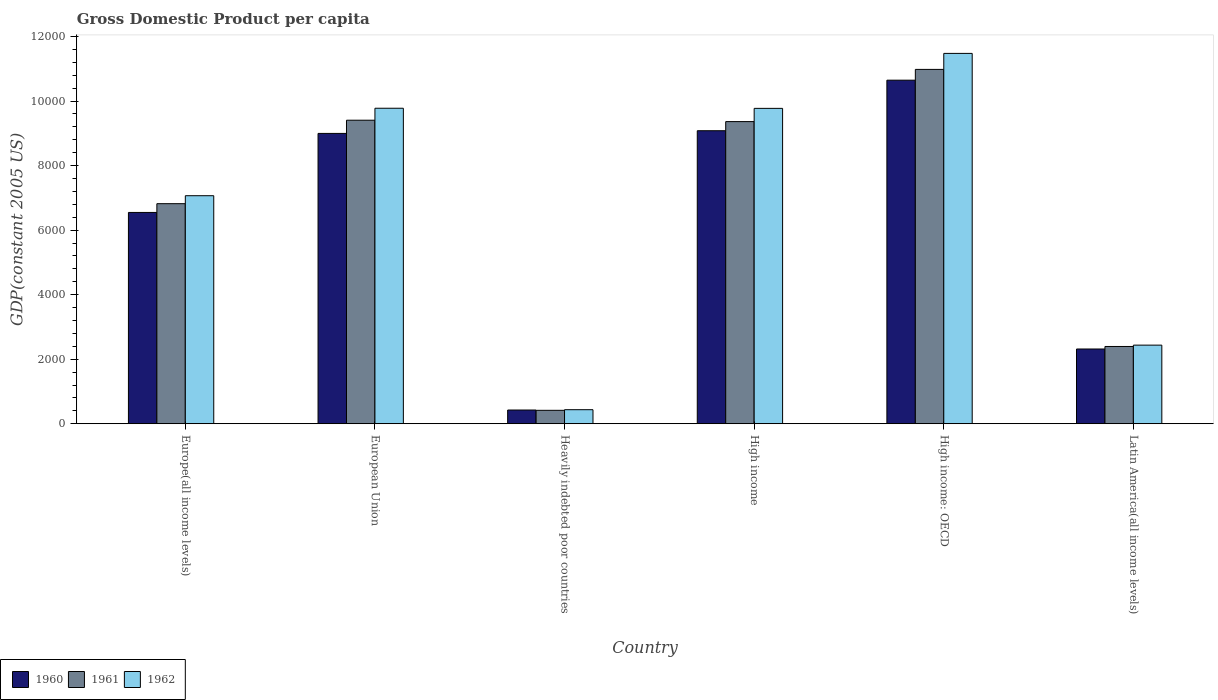Are the number of bars per tick equal to the number of legend labels?
Provide a short and direct response. Yes. How many bars are there on the 4th tick from the left?
Provide a short and direct response. 3. How many bars are there on the 3rd tick from the right?
Ensure brevity in your answer.  3. What is the label of the 6th group of bars from the left?
Your answer should be very brief. Latin America(all income levels). In how many cases, is the number of bars for a given country not equal to the number of legend labels?
Keep it short and to the point. 0. What is the GDP per capita in 1962 in Europe(all income levels)?
Provide a short and direct response. 7066.73. Across all countries, what is the maximum GDP per capita in 1961?
Give a very brief answer. 1.10e+04. Across all countries, what is the minimum GDP per capita in 1960?
Provide a short and direct response. 424.89. In which country was the GDP per capita in 1962 maximum?
Your answer should be compact. High income: OECD. In which country was the GDP per capita in 1962 minimum?
Ensure brevity in your answer.  Heavily indebted poor countries. What is the total GDP per capita in 1962 in the graph?
Offer a terse response. 4.10e+04. What is the difference between the GDP per capita in 1960 in Europe(all income levels) and that in High income?
Your answer should be compact. -2532.78. What is the difference between the GDP per capita in 1962 in Heavily indebted poor countries and the GDP per capita in 1960 in High income?
Ensure brevity in your answer.  -8645.59. What is the average GDP per capita in 1962 per country?
Provide a short and direct response. 6827.66. What is the difference between the GDP per capita of/in 1960 and GDP per capita of/in 1962 in European Union?
Your answer should be very brief. -779.83. What is the ratio of the GDP per capita in 1960 in European Union to that in Heavily indebted poor countries?
Your response must be concise. 21.18. What is the difference between the highest and the second highest GDP per capita in 1960?
Ensure brevity in your answer.  83.28. What is the difference between the highest and the lowest GDP per capita in 1961?
Your answer should be very brief. 1.06e+04. Is the sum of the GDP per capita in 1960 in European Union and Latin America(all income levels) greater than the maximum GDP per capita in 1961 across all countries?
Ensure brevity in your answer.  Yes. Is it the case that in every country, the sum of the GDP per capita in 1961 and GDP per capita in 1960 is greater than the GDP per capita in 1962?
Your answer should be very brief. Yes. Are all the bars in the graph horizontal?
Make the answer very short. No. How many countries are there in the graph?
Your response must be concise. 6. What is the difference between two consecutive major ticks on the Y-axis?
Offer a terse response. 2000. Where does the legend appear in the graph?
Provide a short and direct response. Bottom left. How many legend labels are there?
Make the answer very short. 3. How are the legend labels stacked?
Your response must be concise. Horizontal. What is the title of the graph?
Provide a succinct answer. Gross Domestic Product per capita. What is the label or title of the X-axis?
Your answer should be very brief. Country. What is the label or title of the Y-axis?
Keep it short and to the point. GDP(constant 2005 US). What is the GDP(constant 2005 US) of 1960 in Europe(all income levels)?
Your answer should be very brief. 6547.96. What is the GDP(constant 2005 US) in 1961 in Europe(all income levels)?
Offer a terse response. 6819.79. What is the GDP(constant 2005 US) of 1962 in Europe(all income levels)?
Your response must be concise. 7066.73. What is the GDP(constant 2005 US) of 1960 in European Union?
Provide a succinct answer. 8997.47. What is the GDP(constant 2005 US) of 1961 in European Union?
Ensure brevity in your answer.  9406.28. What is the GDP(constant 2005 US) of 1962 in European Union?
Provide a short and direct response. 9777.3. What is the GDP(constant 2005 US) of 1960 in Heavily indebted poor countries?
Make the answer very short. 424.89. What is the GDP(constant 2005 US) in 1961 in Heavily indebted poor countries?
Give a very brief answer. 415.63. What is the GDP(constant 2005 US) in 1962 in Heavily indebted poor countries?
Keep it short and to the point. 435.15. What is the GDP(constant 2005 US) in 1960 in High income?
Provide a succinct answer. 9080.74. What is the GDP(constant 2005 US) of 1961 in High income?
Your answer should be very brief. 9363.39. What is the GDP(constant 2005 US) in 1962 in High income?
Make the answer very short. 9773.42. What is the GDP(constant 2005 US) in 1960 in High income: OECD?
Ensure brevity in your answer.  1.06e+04. What is the GDP(constant 2005 US) in 1961 in High income: OECD?
Give a very brief answer. 1.10e+04. What is the GDP(constant 2005 US) in 1962 in High income: OECD?
Your answer should be very brief. 1.15e+04. What is the GDP(constant 2005 US) of 1960 in Latin America(all income levels)?
Provide a succinct answer. 2316.36. What is the GDP(constant 2005 US) in 1961 in Latin America(all income levels)?
Offer a very short reply. 2394.33. What is the GDP(constant 2005 US) in 1962 in Latin America(all income levels)?
Ensure brevity in your answer.  2436.18. Across all countries, what is the maximum GDP(constant 2005 US) of 1960?
Give a very brief answer. 1.06e+04. Across all countries, what is the maximum GDP(constant 2005 US) of 1961?
Give a very brief answer. 1.10e+04. Across all countries, what is the maximum GDP(constant 2005 US) in 1962?
Your answer should be very brief. 1.15e+04. Across all countries, what is the minimum GDP(constant 2005 US) of 1960?
Your response must be concise. 424.89. Across all countries, what is the minimum GDP(constant 2005 US) of 1961?
Provide a succinct answer. 415.63. Across all countries, what is the minimum GDP(constant 2005 US) in 1962?
Ensure brevity in your answer.  435.15. What is the total GDP(constant 2005 US) of 1960 in the graph?
Offer a very short reply. 3.80e+04. What is the total GDP(constant 2005 US) of 1961 in the graph?
Ensure brevity in your answer.  3.94e+04. What is the total GDP(constant 2005 US) in 1962 in the graph?
Your answer should be compact. 4.10e+04. What is the difference between the GDP(constant 2005 US) in 1960 in Europe(all income levels) and that in European Union?
Your answer should be compact. -2449.5. What is the difference between the GDP(constant 2005 US) of 1961 in Europe(all income levels) and that in European Union?
Offer a very short reply. -2586.48. What is the difference between the GDP(constant 2005 US) in 1962 in Europe(all income levels) and that in European Union?
Your answer should be compact. -2710.56. What is the difference between the GDP(constant 2005 US) of 1960 in Europe(all income levels) and that in Heavily indebted poor countries?
Your response must be concise. 6123.07. What is the difference between the GDP(constant 2005 US) of 1961 in Europe(all income levels) and that in Heavily indebted poor countries?
Give a very brief answer. 6404.17. What is the difference between the GDP(constant 2005 US) in 1962 in Europe(all income levels) and that in Heavily indebted poor countries?
Give a very brief answer. 6631.58. What is the difference between the GDP(constant 2005 US) in 1960 in Europe(all income levels) and that in High income?
Provide a short and direct response. -2532.78. What is the difference between the GDP(constant 2005 US) of 1961 in Europe(all income levels) and that in High income?
Provide a short and direct response. -2543.6. What is the difference between the GDP(constant 2005 US) in 1962 in Europe(all income levels) and that in High income?
Make the answer very short. -2706.68. What is the difference between the GDP(constant 2005 US) of 1960 in Europe(all income levels) and that in High income: OECD?
Your answer should be compact. -4099.09. What is the difference between the GDP(constant 2005 US) in 1961 in Europe(all income levels) and that in High income: OECD?
Your answer should be compact. -4161.11. What is the difference between the GDP(constant 2005 US) of 1962 in Europe(all income levels) and that in High income: OECD?
Your answer should be very brief. -4410.44. What is the difference between the GDP(constant 2005 US) in 1960 in Europe(all income levels) and that in Latin America(all income levels)?
Your answer should be compact. 4231.61. What is the difference between the GDP(constant 2005 US) in 1961 in Europe(all income levels) and that in Latin America(all income levels)?
Your response must be concise. 4425.47. What is the difference between the GDP(constant 2005 US) of 1962 in Europe(all income levels) and that in Latin America(all income levels)?
Make the answer very short. 4630.56. What is the difference between the GDP(constant 2005 US) in 1960 in European Union and that in Heavily indebted poor countries?
Offer a terse response. 8572.57. What is the difference between the GDP(constant 2005 US) of 1961 in European Union and that in Heavily indebted poor countries?
Make the answer very short. 8990.65. What is the difference between the GDP(constant 2005 US) of 1962 in European Union and that in Heavily indebted poor countries?
Make the answer very short. 9342.14. What is the difference between the GDP(constant 2005 US) of 1960 in European Union and that in High income?
Your answer should be very brief. -83.28. What is the difference between the GDP(constant 2005 US) of 1961 in European Union and that in High income?
Your answer should be compact. 42.89. What is the difference between the GDP(constant 2005 US) of 1962 in European Union and that in High income?
Provide a short and direct response. 3.88. What is the difference between the GDP(constant 2005 US) of 1960 in European Union and that in High income: OECD?
Provide a succinct answer. -1649.59. What is the difference between the GDP(constant 2005 US) of 1961 in European Union and that in High income: OECD?
Offer a very short reply. -1574.63. What is the difference between the GDP(constant 2005 US) in 1962 in European Union and that in High income: OECD?
Offer a very short reply. -1699.88. What is the difference between the GDP(constant 2005 US) in 1960 in European Union and that in Latin America(all income levels)?
Your answer should be compact. 6681.11. What is the difference between the GDP(constant 2005 US) of 1961 in European Union and that in Latin America(all income levels)?
Ensure brevity in your answer.  7011.95. What is the difference between the GDP(constant 2005 US) of 1962 in European Union and that in Latin America(all income levels)?
Provide a succinct answer. 7341.12. What is the difference between the GDP(constant 2005 US) in 1960 in Heavily indebted poor countries and that in High income?
Keep it short and to the point. -8655.85. What is the difference between the GDP(constant 2005 US) of 1961 in Heavily indebted poor countries and that in High income?
Provide a short and direct response. -8947.77. What is the difference between the GDP(constant 2005 US) in 1962 in Heavily indebted poor countries and that in High income?
Provide a succinct answer. -9338.26. What is the difference between the GDP(constant 2005 US) in 1960 in Heavily indebted poor countries and that in High income: OECD?
Ensure brevity in your answer.  -1.02e+04. What is the difference between the GDP(constant 2005 US) of 1961 in Heavily indebted poor countries and that in High income: OECD?
Keep it short and to the point. -1.06e+04. What is the difference between the GDP(constant 2005 US) in 1962 in Heavily indebted poor countries and that in High income: OECD?
Provide a short and direct response. -1.10e+04. What is the difference between the GDP(constant 2005 US) in 1960 in Heavily indebted poor countries and that in Latin America(all income levels)?
Provide a short and direct response. -1891.46. What is the difference between the GDP(constant 2005 US) of 1961 in Heavily indebted poor countries and that in Latin America(all income levels)?
Give a very brief answer. -1978.7. What is the difference between the GDP(constant 2005 US) of 1962 in Heavily indebted poor countries and that in Latin America(all income levels)?
Offer a terse response. -2001.03. What is the difference between the GDP(constant 2005 US) of 1960 in High income and that in High income: OECD?
Provide a short and direct response. -1566.31. What is the difference between the GDP(constant 2005 US) in 1961 in High income and that in High income: OECD?
Keep it short and to the point. -1617.52. What is the difference between the GDP(constant 2005 US) of 1962 in High income and that in High income: OECD?
Ensure brevity in your answer.  -1703.76. What is the difference between the GDP(constant 2005 US) of 1960 in High income and that in Latin America(all income levels)?
Your answer should be compact. 6764.39. What is the difference between the GDP(constant 2005 US) in 1961 in High income and that in Latin America(all income levels)?
Provide a succinct answer. 6969.06. What is the difference between the GDP(constant 2005 US) in 1962 in High income and that in Latin America(all income levels)?
Offer a very short reply. 7337.24. What is the difference between the GDP(constant 2005 US) in 1960 in High income: OECD and that in Latin America(all income levels)?
Ensure brevity in your answer.  8330.7. What is the difference between the GDP(constant 2005 US) in 1961 in High income: OECD and that in Latin America(all income levels)?
Your answer should be very brief. 8586.58. What is the difference between the GDP(constant 2005 US) of 1962 in High income: OECD and that in Latin America(all income levels)?
Offer a terse response. 9041. What is the difference between the GDP(constant 2005 US) of 1960 in Europe(all income levels) and the GDP(constant 2005 US) of 1961 in European Union?
Provide a succinct answer. -2858.31. What is the difference between the GDP(constant 2005 US) in 1960 in Europe(all income levels) and the GDP(constant 2005 US) in 1962 in European Union?
Provide a succinct answer. -3229.33. What is the difference between the GDP(constant 2005 US) of 1961 in Europe(all income levels) and the GDP(constant 2005 US) of 1962 in European Union?
Keep it short and to the point. -2957.5. What is the difference between the GDP(constant 2005 US) in 1960 in Europe(all income levels) and the GDP(constant 2005 US) in 1961 in Heavily indebted poor countries?
Make the answer very short. 6132.34. What is the difference between the GDP(constant 2005 US) in 1960 in Europe(all income levels) and the GDP(constant 2005 US) in 1962 in Heavily indebted poor countries?
Your response must be concise. 6112.81. What is the difference between the GDP(constant 2005 US) of 1961 in Europe(all income levels) and the GDP(constant 2005 US) of 1962 in Heavily indebted poor countries?
Keep it short and to the point. 6384.64. What is the difference between the GDP(constant 2005 US) in 1960 in Europe(all income levels) and the GDP(constant 2005 US) in 1961 in High income?
Ensure brevity in your answer.  -2815.43. What is the difference between the GDP(constant 2005 US) of 1960 in Europe(all income levels) and the GDP(constant 2005 US) of 1962 in High income?
Provide a succinct answer. -3225.45. What is the difference between the GDP(constant 2005 US) in 1961 in Europe(all income levels) and the GDP(constant 2005 US) in 1962 in High income?
Give a very brief answer. -2953.62. What is the difference between the GDP(constant 2005 US) of 1960 in Europe(all income levels) and the GDP(constant 2005 US) of 1961 in High income: OECD?
Ensure brevity in your answer.  -4432.94. What is the difference between the GDP(constant 2005 US) in 1960 in Europe(all income levels) and the GDP(constant 2005 US) in 1962 in High income: OECD?
Your response must be concise. -4929.21. What is the difference between the GDP(constant 2005 US) in 1961 in Europe(all income levels) and the GDP(constant 2005 US) in 1962 in High income: OECD?
Make the answer very short. -4657.38. What is the difference between the GDP(constant 2005 US) of 1960 in Europe(all income levels) and the GDP(constant 2005 US) of 1961 in Latin America(all income levels)?
Give a very brief answer. 4153.64. What is the difference between the GDP(constant 2005 US) in 1960 in Europe(all income levels) and the GDP(constant 2005 US) in 1962 in Latin America(all income levels)?
Give a very brief answer. 4111.79. What is the difference between the GDP(constant 2005 US) in 1961 in Europe(all income levels) and the GDP(constant 2005 US) in 1962 in Latin America(all income levels)?
Give a very brief answer. 4383.62. What is the difference between the GDP(constant 2005 US) of 1960 in European Union and the GDP(constant 2005 US) of 1961 in Heavily indebted poor countries?
Keep it short and to the point. 8581.84. What is the difference between the GDP(constant 2005 US) of 1960 in European Union and the GDP(constant 2005 US) of 1962 in Heavily indebted poor countries?
Ensure brevity in your answer.  8562.31. What is the difference between the GDP(constant 2005 US) in 1961 in European Union and the GDP(constant 2005 US) in 1962 in Heavily indebted poor countries?
Provide a succinct answer. 8971.13. What is the difference between the GDP(constant 2005 US) of 1960 in European Union and the GDP(constant 2005 US) of 1961 in High income?
Offer a very short reply. -365.92. What is the difference between the GDP(constant 2005 US) in 1960 in European Union and the GDP(constant 2005 US) in 1962 in High income?
Your answer should be very brief. -775.95. What is the difference between the GDP(constant 2005 US) of 1961 in European Union and the GDP(constant 2005 US) of 1962 in High income?
Your response must be concise. -367.14. What is the difference between the GDP(constant 2005 US) of 1960 in European Union and the GDP(constant 2005 US) of 1961 in High income: OECD?
Your answer should be very brief. -1983.44. What is the difference between the GDP(constant 2005 US) in 1960 in European Union and the GDP(constant 2005 US) in 1962 in High income: OECD?
Offer a terse response. -2479.71. What is the difference between the GDP(constant 2005 US) of 1961 in European Union and the GDP(constant 2005 US) of 1962 in High income: OECD?
Provide a short and direct response. -2070.9. What is the difference between the GDP(constant 2005 US) of 1960 in European Union and the GDP(constant 2005 US) of 1961 in Latin America(all income levels)?
Your answer should be very brief. 6603.14. What is the difference between the GDP(constant 2005 US) in 1960 in European Union and the GDP(constant 2005 US) in 1962 in Latin America(all income levels)?
Make the answer very short. 6561.29. What is the difference between the GDP(constant 2005 US) in 1961 in European Union and the GDP(constant 2005 US) in 1962 in Latin America(all income levels)?
Keep it short and to the point. 6970.1. What is the difference between the GDP(constant 2005 US) in 1960 in Heavily indebted poor countries and the GDP(constant 2005 US) in 1961 in High income?
Keep it short and to the point. -8938.5. What is the difference between the GDP(constant 2005 US) in 1960 in Heavily indebted poor countries and the GDP(constant 2005 US) in 1962 in High income?
Provide a succinct answer. -9348.52. What is the difference between the GDP(constant 2005 US) of 1961 in Heavily indebted poor countries and the GDP(constant 2005 US) of 1962 in High income?
Your answer should be compact. -9357.79. What is the difference between the GDP(constant 2005 US) in 1960 in Heavily indebted poor countries and the GDP(constant 2005 US) in 1961 in High income: OECD?
Your response must be concise. -1.06e+04. What is the difference between the GDP(constant 2005 US) in 1960 in Heavily indebted poor countries and the GDP(constant 2005 US) in 1962 in High income: OECD?
Ensure brevity in your answer.  -1.11e+04. What is the difference between the GDP(constant 2005 US) in 1961 in Heavily indebted poor countries and the GDP(constant 2005 US) in 1962 in High income: OECD?
Your answer should be compact. -1.11e+04. What is the difference between the GDP(constant 2005 US) in 1960 in Heavily indebted poor countries and the GDP(constant 2005 US) in 1961 in Latin America(all income levels)?
Your response must be concise. -1969.44. What is the difference between the GDP(constant 2005 US) in 1960 in Heavily indebted poor countries and the GDP(constant 2005 US) in 1962 in Latin America(all income levels)?
Offer a terse response. -2011.29. What is the difference between the GDP(constant 2005 US) of 1961 in Heavily indebted poor countries and the GDP(constant 2005 US) of 1962 in Latin America(all income levels)?
Your answer should be very brief. -2020.55. What is the difference between the GDP(constant 2005 US) in 1960 in High income and the GDP(constant 2005 US) in 1961 in High income: OECD?
Give a very brief answer. -1900.16. What is the difference between the GDP(constant 2005 US) in 1960 in High income and the GDP(constant 2005 US) in 1962 in High income: OECD?
Your answer should be very brief. -2396.44. What is the difference between the GDP(constant 2005 US) in 1961 in High income and the GDP(constant 2005 US) in 1962 in High income: OECD?
Keep it short and to the point. -2113.79. What is the difference between the GDP(constant 2005 US) of 1960 in High income and the GDP(constant 2005 US) of 1961 in Latin America(all income levels)?
Provide a short and direct response. 6686.42. What is the difference between the GDP(constant 2005 US) of 1960 in High income and the GDP(constant 2005 US) of 1962 in Latin America(all income levels)?
Give a very brief answer. 6644.56. What is the difference between the GDP(constant 2005 US) of 1961 in High income and the GDP(constant 2005 US) of 1962 in Latin America(all income levels)?
Provide a short and direct response. 6927.21. What is the difference between the GDP(constant 2005 US) in 1960 in High income: OECD and the GDP(constant 2005 US) in 1961 in Latin America(all income levels)?
Keep it short and to the point. 8252.73. What is the difference between the GDP(constant 2005 US) in 1960 in High income: OECD and the GDP(constant 2005 US) in 1962 in Latin America(all income levels)?
Your answer should be compact. 8210.87. What is the difference between the GDP(constant 2005 US) of 1961 in High income: OECD and the GDP(constant 2005 US) of 1962 in Latin America(all income levels)?
Ensure brevity in your answer.  8544.73. What is the average GDP(constant 2005 US) in 1960 per country?
Keep it short and to the point. 6335.75. What is the average GDP(constant 2005 US) in 1961 per country?
Give a very brief answer. 6563.39. What is the average GDP(constant 2005 US) in 1962 per country?
Give a very brief answer. 6827.66. What is the difference between the GDP(constant 2005 US) in 1960 and GDP(constant 2005 US) in 1961 in Europe(all income levels)?
Your answer should be compact. -271.83. What is the difference between the GDP(constant 2005 US) in 1960 and GDP(constant 2005 US) in 1962 in Europe(all income levels)?
Provide a short and direct response. -518.77. What is the difference between the GDP(constant 2005 US) of 1961 and GDP(constant 2005 US) of 1962 in Europe(all income levels)?
Your response must be concise. -246.94. What is the difference between the GDP(constant 2005 US) of 1960 and GDP(constant 2005 US) of 1961 in European Union?
Offer a terse response. -408.81. What is the difference between the GDP(constant 2005 US) of 1960 and GDP(constant 2005 US) of 1962 in European Union?
Offer a terse response. -779.83. What is the difference between the GDP(constant 2005 US) of 1961 and GDP(constant 2005 US) of 1962 in European Union?
Your answer should be compact. -371.02. What is the difference between the GDP(constant 2005 US) in 1960 and GDP(constant 2005 US) in 1961 in Heavily indebted poor countries?
Your answer should be compact. 9.27. What is the difference between the GDP(constant 2005 US) in 1960 and GDP(constant 2005 US) in 1962 in Heavily indebted poor countries?
Your answer should be compact. -10.26. What is the difference between the GDP(constant 2005 US) of 1961 and GDP(constant 2005 US) of 1962 in Heavily indebted poor countries?
Provide a short and direct response. -19.53. What is the difference between the GDP(constant 2005 US) of 1960 and GDP(constant 2005 US) of 1961 in High income?
Ensure brevity in your answer.  -282.65. What is the difference between the GDP(constant 2005 US) in 1960 and GDP(constant 2005 US) in 1962 in High income?
Make the answer very short. -692.67. What is the difference between the GDP(constant 2005 US) of 1961 and GDP(constant 2005 US) of 1962 in High income?
Your answer should be compact. -410.03. What is the difference between the GDP(constant 2005 US) of 1960 and GDP(constant 2005 US) of 1961 in High income: OECD?
Make the answer very short. -333.85. What is the difference between the GDP(constant 2005 US) of 1960 and GDP(constant 2005 US) of 1962 in High income: OECD?
Offer a very short reply. -830.12. What is the difference between the GDP(constant 2005 US) of 1961 and GDP(constant 2005 US) of 1962 in High income: OECD?
Give a very brief answer. -496.27. What is the difference between the GDP(constant 2005 US) of 1960 and GDP(constant 2005 US) of 1961 in Latin America(all income levels)?
Make the answer very short. -77.97. What is the difference between the GDP(constant 2005 US) in 1960 and GDP(constant 2005 US) in 1962 in Latin America(all income levels)?
Offer a terse response. -119.82. What is the difference between the GDP(constant 2005 US) of 1961 and GDP(constant 2005 US) of 1962 in Latin America(all income levels)?
Ensure brevity in your answer.  -41.85. What is the ratio of the GDP(constant 2005 US) of 1960 in Europe(all income levels) to that in European Union?
Your response must be concise. 0.73. What is the ratio of the GDP(constant 2005 US) in 1961 in Europe(all income levels) to that in European Union?
Offer a terse response. 0.72. What is the ratio of the GDP(constant 2005 US) of 1962 in Europe(all income levels) to that in European Union?
Offer a terse response. 0.72. What is the ratio of the GDP(constant 2005 US) of 1960 in Europe(all income levels) to that in Heavily indebted poor countries?
Make the answer very short. 15.41. What is the ratio of the GDP(constant 2005 US) in 1961 in Europe(all income levels) to that in Heavily indebted poor countries?
Make the answer very short. 16.41. What is the ratio of the GDP(constant 2005 US) of 1962 in Europe(all income levels) to that in Heavily indebted poor countries?
Your answer should be compact. 16.24. What is the ratio of the GDP(constant 2005 US) in 1960 in Europe(all income levels) to that in High income?
Ensure brevity in your answer.  0.72. What is the ratio of the GDP(constant 2005 US) in 1961 in Europe(all income levels) to that in High income?
Offer a terse response. 0.73. What is the ratio of the GDP(constant 2005 US) of 1962 in Europe(all income levels) to that in High income?
Provide a short and direct response. 0.72. What is the ratio of the GDP(constant 2005 US) of 1960 in Europe(all income levels) to that in High income: OECD?
Offer a terse response. 0.61. What is the ratio of the GDP(constant 2005 US) of 1961 in Europe(all income levels) to that in High income: OECD?
Offer a very short reply. 0.62. What is the ratio of the GDP(constant 2005 US) in 1962 in Europe(all income levels) to that in High income: OECD?
Provide a short and direct response. 0.62. What is the ratio of the GDP(constant 2005 US) of 1960 in Europe(all income levels) to that in Latin America(all income levels)?
Make the answer very short. 2.83. What is the ratio of the GDP(constant 2005 US) of 1961 in Europe(all income levels) to that in Latin America(all income levels)?
Your answer should be very brief. 2.85. What is the ratio of the GDP(constant 2005 US) in 1962 in Europe(all income levels) to that in Latin America(all income levels)?
Provide a succinct answer. 2.9. What is the ratio of the GDP(constant 2005 US) in 1960 in European Union to that in Heavily indebted poor countries?
Offer a very short reply. 21.18. What is the ratio of the GDP(constant 2005 US) in 1961 in European Union to that in Heavily indebted poor countries?
Your answer should be very brief. 22.63. What is the ratio of the GDP(constant 2005 US) in 1962 in European Union to that in Heavily indebted poor countries?
Your answer should be very brief. 22.47. What is the ratio of the GDP(constant 2005 US) of 1960 in European Union to that in High income?
Provide a short and direct response. 0.99. What is the ratio of the GDP(constant 2005 US) in 1961 in European Union to that in High income?
Make the answer very short. 1. What is the ratio of the GDP(constant 2005 US) of 1960 in European Union to that in High income: OECD?
Make the answer very short. 0.85. What is the ratio of the GDP(constant 2005 US) of 1961 in European Union to that in High income: OECD?
Your answer should be compact. 0.86. What is the ratio of the GDP(constant 2005 US) of 1962 in European Union to that in High income: OECD?
Provide a short and direct response. 0.85. What is the ratio of the GDP(constant 2005 US) in 1960 in European Union to that in Latin America(all income levels)?
Provide a succinct answer. 3.88. What is the ratio of the GDP(constant 2005 US) in 1961 in European Union to that in Latin America(all income levels)?
Ensure brevity in your answer.  3.93. What is the ratio of the GDP(constant 2005 US) in 1962 in European Union to that in Latin America(all income levels)?
Provide a succinct answer. 4.01. What is the ratio of the GDP(constant 2005 US) of 1960 in Heavily indebted poor countries to that in High income?
Your response must be concise. 0.05. What is the ratio of the GDP(constant 2005 US) in 1961 in Heavily indebted poor countries to that in High income?
Offer a terse response. 0.04. What is the ratio of the GDP(constant 2005 US) of 1962 in Heavily indebted poor countries to that in High income?
Offer a terse response. 0.04. What is the ratio of the GDP(constant 2005 US) of 1960 in Heavily indebted poor countries to that in High income: OECD?
Provide a succinct answer. 0.04. What is the ratio of the GDP(constant 2005 US) in 1961 in Heavily indebted poor countries to that in High income: OECD?
Give a very brief answer. 0.04. What is the ratio of the GDP(constant 2005 US) of 1962 in Heavily indebted poor countries to that in High income: OECD?
Offer a terse response. 0.04. What is the ratio of the GDP(constant 2005 US) in 1960 in Heavily indebted poor countries to that in Latin America(all income levels)?
Keep it short and to the point. 0.18. What is the ratio of the GDP(constant 2005 US) in 1961 in Heavily indebted poor countries to that in Latin America(all income levels)?
Make the answer very short. 0.17. What is the ratio of the GDP(constant 2005 US) in 1962 in Heavily indebted poor countries to that in Latin America(all income levels)?
Your answer should be compact. 0.18. What is the ratio of the GDP(constant 2005 US) of 1960 in High income to that in High income: OECD?
Keep it short and to the point. 0.85. What is the ratio of the GDP(constant 2005 US) in 1961 in High income to that in High income: OECD?
Keep it short and to the point. 0.85. What is the ratio of the GDP(constant 2005 US) in 1962 in High income to that in High income: OECD?
Offer a very short reply. 0.85. What is the ratio of the GDP(constant 2005 US) in 1960 in High income to that in Latin America(all income levels)?
Provide a succinct answer. 3.92. What is the ratio of the GDP(constant 2005 US) of 1961 in High income to that in Latin America(all income levels)?
Make the answer very short. 3.91. What is the ratio of the GDP(constant 2005 US) of 1962 in High income to that in Latin America(all income levels)?
Offer a very short reply. 4.01. What is the ratio of the GDP(constant 2005 US) in 1960 in High income: OECD to that in Latin America(all income levels)?
Offer a very short reply. 4.6. What is the ratio of the GDP(constant 2005 US) in 1961 in High income: OECD to that in Latin America(all income levels)?
Offer a very short reply. 4.59. What is the ratio of the GDP(constant 2005 US) of 1962 in High income: OECD to that in Latin America(all income levels)?
Provide a succinct answer. 4.71. What is the difference between the highest and the second highest GDP(constant 2005 US) of 1960?
Your answer should be very brief. 1566.31. What is the difference between the highest and the second highest GDP(constant 2005 US) of 1961?
Provide a succinct answer. 1574.63. What is the difference between the highest and the second highest GDP(constant 2005 US) of 1962?
Your response must be concise. 1699.88. What is the difference between the highest and the lowest GDP(constant 2005 US) in 1960?
Your answer should be compact. 1.02e+04. What is the difference between the highest and the lowest GDP(constant 2005 US) in 1961?
Offer a very short reply. 1.06e+04. What is the difference between the highest and the lowest GDP(constant 2005 US) in 1962?
Provide a succinct answer. 1.10e+04. 